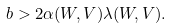Convert formula to latex. <formula><loc_0><loc_0><loc_500><loc_500>b > 2 \alpha ( W , V ) \lambda ( W , V ) .</formula> 